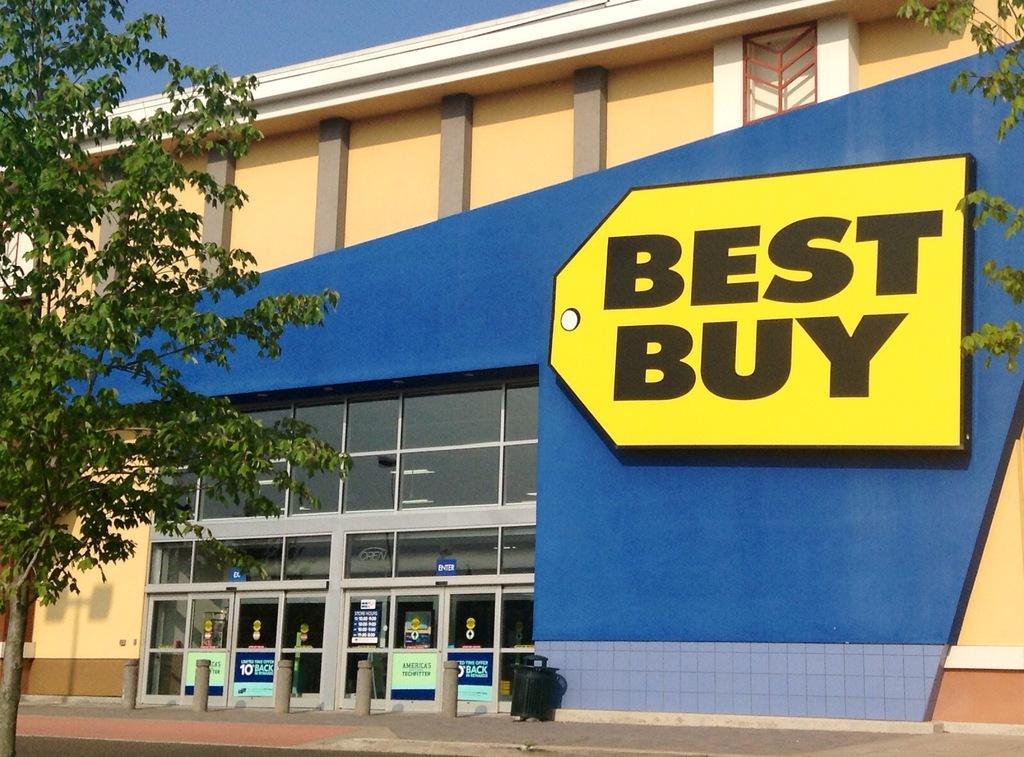Describe this image in one or two sentences. In this image I see a building, which is of blue and cream in color and on the building it is written as "Best Buy". Beside the building there are trees and there is a footpath in front. 